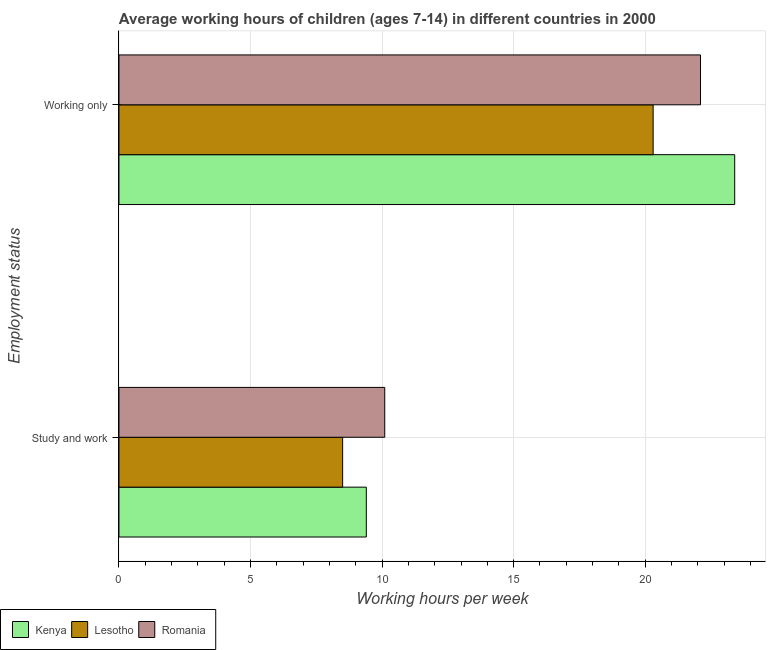How many groups of bars are there?
Offer a very short reply. 2. Are the number of bars per tick equal to the number of legend labels?
Provide a succinct answer. Yes. Are the number of bars on each tick of the Y-axis equal?
Give a very brief answer. Yes. How many bars are there on the 1st tick from the top?
Offer a terse response. 3. What is the label of the 2nd group of bars from the top?
Make the answer very short. Study and work. What is the average working hour of children involved in only work in Kenya?
Offer a very short reply. 23.4. Across all countries, what is the maximum average working hour of children involved in study and work?
Your answer should be compact. 10.1. In which country was the average working hour of children involved in study and work maximum?
Make the answer very short. Romania. In which country was the average working hour of children involved in only work minimum?
Keep it short and to the point. Lesotho. What is the total average working hour of children involved in only work in the graph?
Provide a succinct answer. 65.8. What is the difference between the average working hour of children involved in only work in Lesotho and that in Romania?
Make the answer very short. -1.8. What is the difference between the average working hour of children involved in only work in Kenya and the average working hour of children involved in study and work in Romania?
Give a very brief answer. 13.3. What is the average average working hour of children involved in study and work per country?
Give a very brief answer. 9.33. What is the difference between the average working hour of children involved in study and work and average working hour of children involved in only work in Romania?
Your response must be concise. -12. In how many countries, is the average working hour of children involved in only work greater than 18 hours?
Your response must be concise. 3. What is the ratio of the average working hour of children involved in study and work in Lesotho to that in Kenya?
Provide a short and direct response. 0.9. Is the average working hour of children involved in only work in Romania less than that in Lesotho?
Ensure brevity in your answer.  No. What does the 1st bar from the top in Study and work represents?
Provide a succinct answer. Romania. What does the 2nd bar from the bottom in Study and work represents?
Provide a short and direct response. Lesotho. What is the difference between two consecutive major ticks on the X-axis?
Your answer should be compact. 5. Are the values on the major ticks of X-axis written in scientific E-notation?
Provide a succinct answer. No. Does the graph contain grids?
Keep it short and to the point. Yes. How many legend labels are there?
Ensure brevity in your answer.  3. How are the legend labels stacked?
Your response must be concise. Horizontal. What is the title of the graph?
Keep it short and to the point. Average working hours of children (ages 7-14) in different countries in 2000. What is the label or title of the X-axis?
Give a very brief answer. Working hours per week. What is the label or title of the Y-axis?
Your answer should be very brief. Employment status. What is the Working hours per week in Lesotho in Study and work?
Provide a succinct answer. 8.5. What is the Working hours per week of Romania in Study and work?
Offer a terse response. 10.1. What is the Working hours per week in Kenya in Working only?
Offer a terse response. 23.4. What is the Working hours per week in Lesotho in Working only?
Ensure brevity in your answer.  20.3. What is the Working hours per week in Romania in Working only?
Your response must be concise. 22.1. Across all Employment status, what is the maximum Working hours per week in Kenya?
Offer a terse response. 23.4. Across all Employment status, what is the maximum Working hours per week in Lesotho?
Make the answer very short. 20.3. Across all Employment status, what is the maximum Working hours per week in Romania?
Your answer should be very brief. 22.1. Across all Employment status, what is the minimum Working hours per week of Kenya?
Offer a very short reply. 9.4. Across all Employment status, what is the minimum Working hours per week in Lesotho?
Ensure brevity in your answer.  8.5. What is the total Working hours per week of Kenya in the graph?
Ensure brevity in your answer.  32.8. What is the total Working hours per week of Lesotho in the graph?
Offer a terse response. 28.8. What is the total Working hours per week in Romania in the graph?
Your answer should be compact. 32.2. What is the difference between the Working hours per week of Lesotho in Study and work and that in Working only?
Ensure brevity in your answer.  -11.8. What is the difference between the Working hours per week of Kenya in Study and work and the Working hours per week of Lesotho in Working only?
Give a very brief answer. -10.9. What is the difference between the Working hours per week in Kenya in Study and work and the Working hours per week in Romania in Working only?
Ensure brevity in your answer.  -12.7. What is the difference between the Working hours per week in Lesotho in Study and work and the Working hours per week in Romania in Working only?
Ensure brevity in your answer.  -13.6. What is the average Working hours per week of Lesotho per Employment status?
Your response must be concise. 14.4. What is the difference between the Working hours per week in Kenya and Working hours per week in Lesotho in Working only?
Ensure brevity in your answer.  3.1. What is the difference between the Working hours per week of Lesotho and Working hours per week of Romania in Working only?
Offer a terse response. -1.8. What is the ratio of the Working hours per week of Kenya in Study and work to that in Working only?
Give a very brief answer. 0.4. What is the ratio of the Working hours per week in Lesotho in Study and work to that in Working only?
Make the answer very short. 0.42. What is the ratio of the Working hours per week of Romania in Study and work to that in Working only?
Your answer should be compact. 0.46. What is the difference between the highest and the second highest Working hours per week in Romania?
Provide a short and direct response. 12. What is the difference between the highest and the lowest Working hours per week of Romania?
Make the answer very short. 12. 